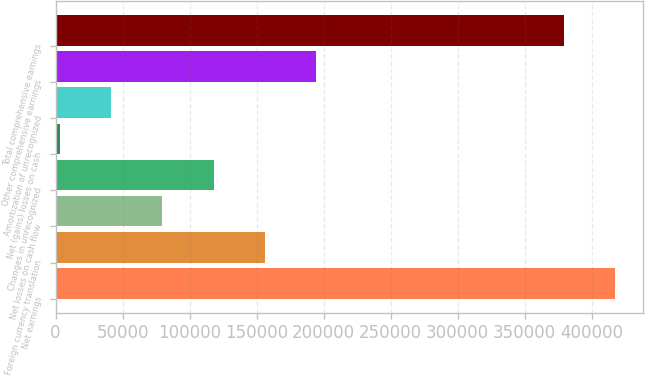Convert chart to OTSL. <chart><loc_0><loc_0><loc_500><loc_500><bar_chart><fcel>Net earnings<fcel>Foreign currency translation<fcel>Net losses on cash flow<fcel>Changes in unrecognized<fcel>Net (gains) losses on cash<fcel>Amortization of unrecognized<fcel>Other comprehensive earnings<fcel>Total comprehensive earnings<nl><fcel>417681<fcel>156150<fcel>79743.8<fcel>117947<fcel>3338<fcel>41540.9<fcel>194352<fcel>379478<nl></chart> 